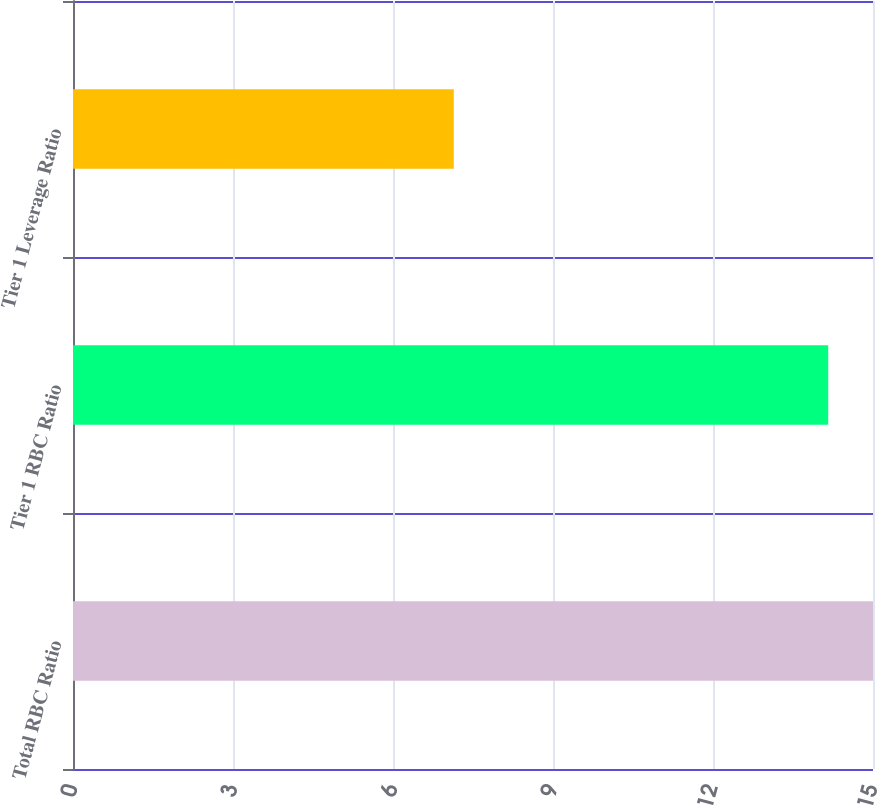<chart> <loc_0><loc_0><loc_500><loc_500><bar_chart><fcel>Total RBC Ratio<fcel>Tier 1 RBC Ratio<fcel>Tier 1 Leverage Ratio<nl><fcel>15<fcel>14.16<fcel>7.14<nl></chart> 